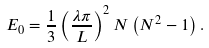Convert formula to latex. <formula><loc_0><loc_0><loc_500><loc_500>E _ { 0 } = \frac { 1 } { 3 } \left ( \frac { \lambda \pi } { L } \right ) ^ { 2 } N \left ( N ^ { 2 } - 1 \right ) .</formula> 